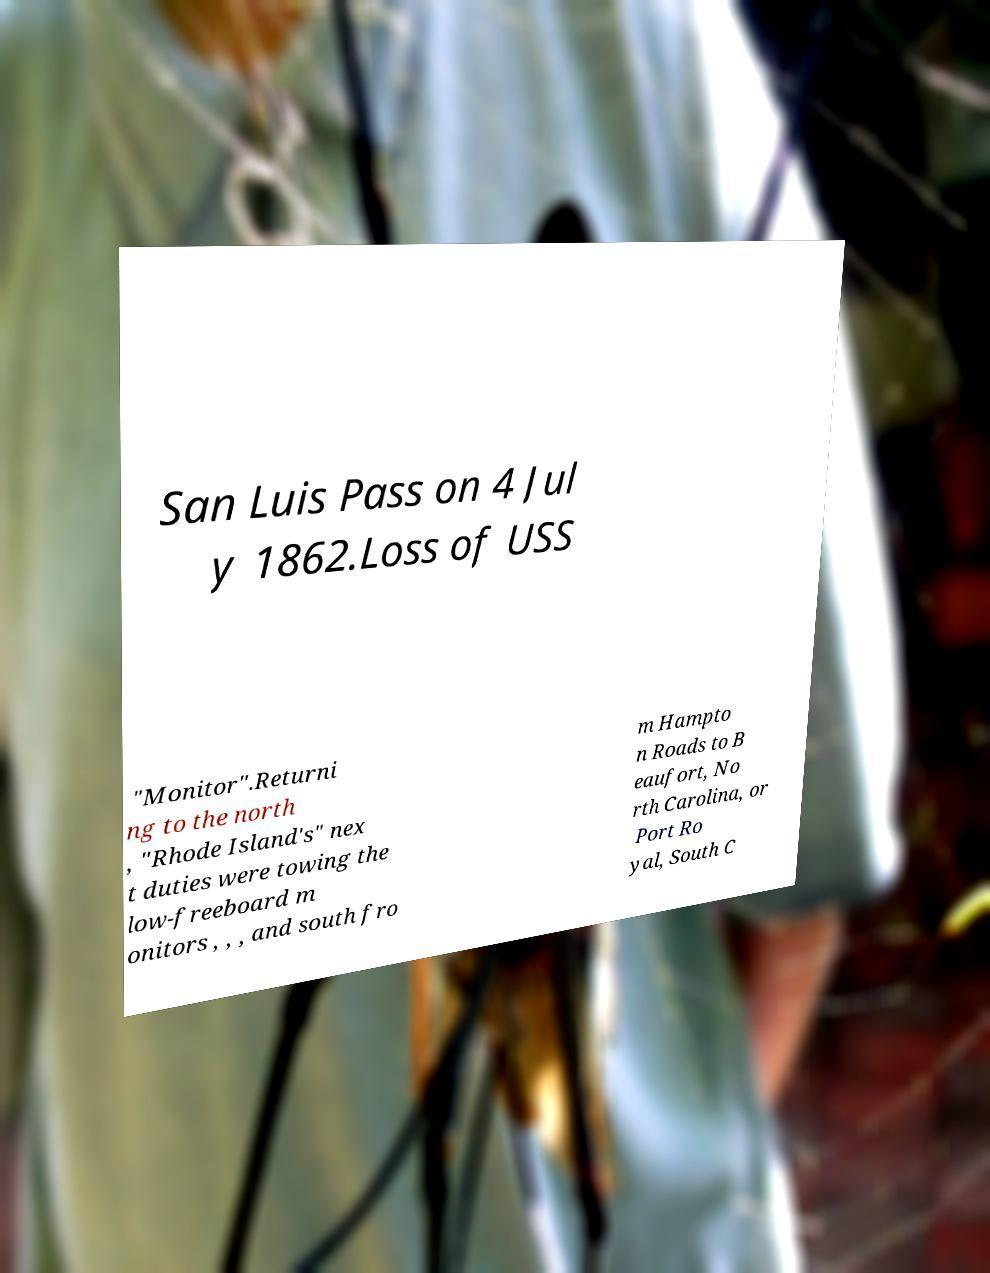Can you accurately transcribe the text from the provided image for me? San Luis Pass on 4 Jul y 1862.Loss of USS "Monitor".Returni ng to the north , "Rhode Island's" nex t duties were towing the low-freeboard m onitors , , , and south fro m Hampto n Roads to B eaufort, No rth Carolina, or Port Ro yal, South C 